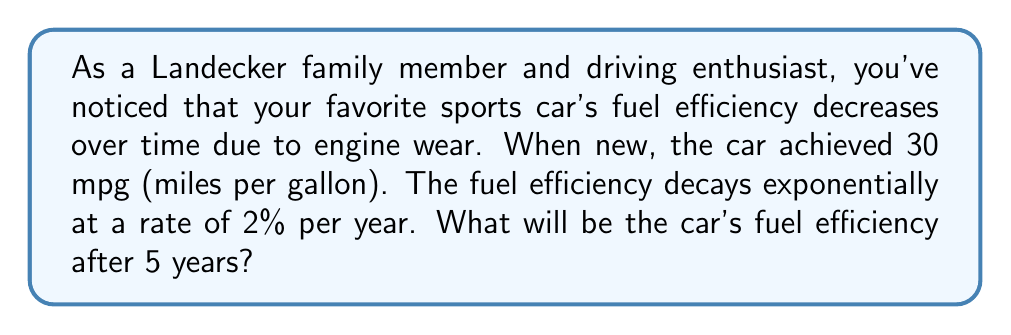Show me your answer to this math problem. Let's approach this step-by-step using the exponential decay formula:

1) The exponential decay formula is:
   $$ A(t) = A_0 \cdot (1-r)^t $$
   where:
   $A(t)$ is the value after time $t$
   $A_0$ is the initial value
   $r$ is the decay rate
   $t$ is the time

2) In this problem:
   $A_0 = 30$ mpg (initial fuel efficiency)
   $r = 0.02$ (2% decay rate)
   $t = 5$ years

3) Plugging these values into the formula:
   $$ A(5) = 30 \cdot (1-0.02)^5 $$

4) Simplify inside the parentheses:
   $$ A(5) = 30 \cdot (0.98)^5 $$

5) Calculate $(0.98)^5$:
   $$ A(5) = 30 \cdot 0.9039 $$

6) Multiply:
   $$ A(5) = 27.117 $$

7) Round to two decimal places:
   $$ A(5) \approx 27.12 \text{ mpg} $$

Therefore, after 5 years, the car's fuel efficiency will be approximately 27.12 mpg.
Answer: 27.12 mpg 